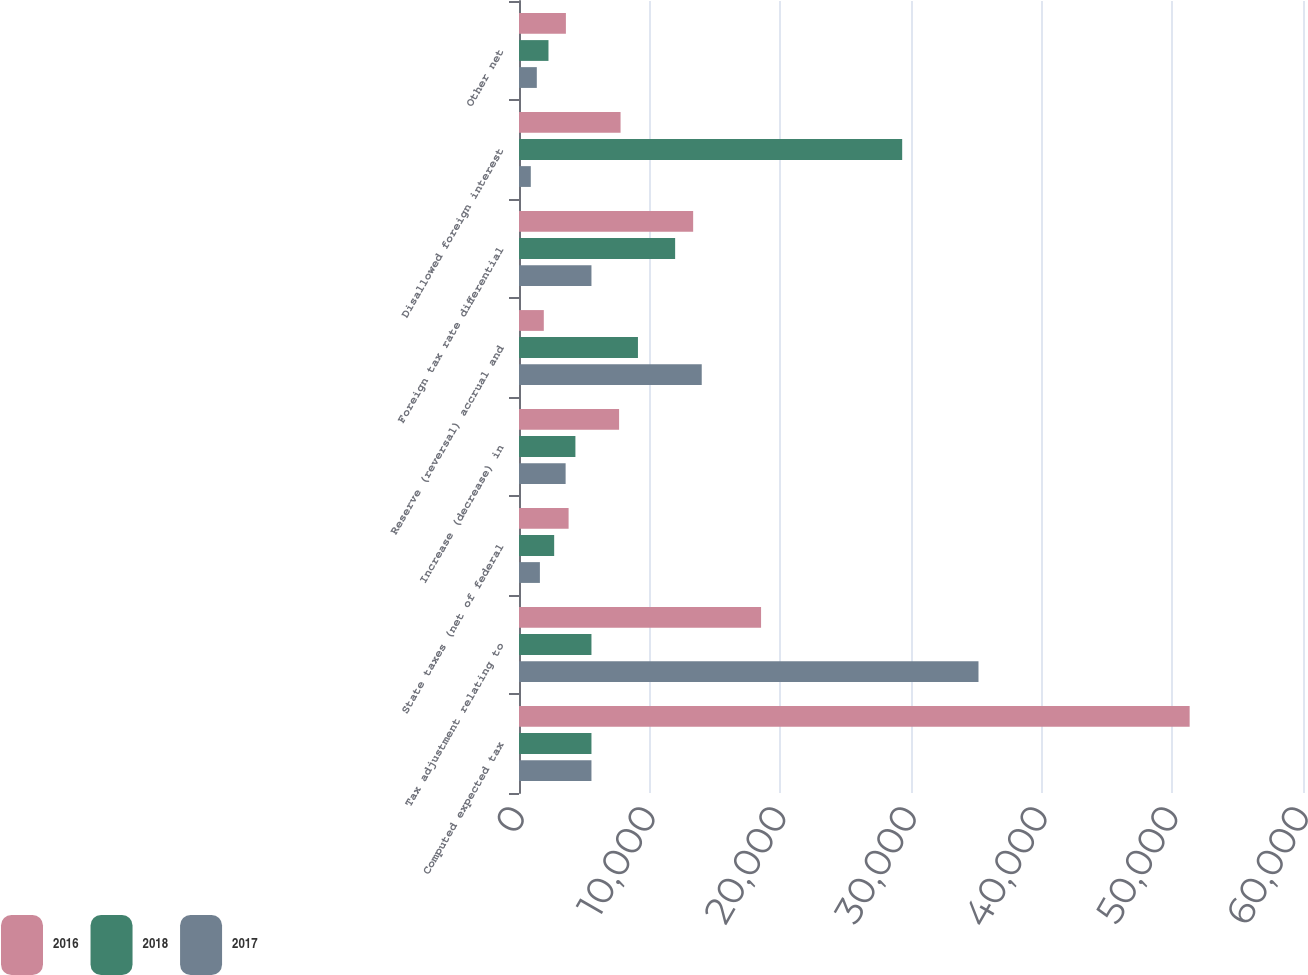<chart> <loc_0><loc_0><loc_500><loc_500><stacked_bar_chart><ecel><fcel>Computed expected tax<fcel>Tax adjustment relating to<fcel>State taxes (net of federal<fcel>Increase (decrease) in<fcel>Reserve (reversal) accrual and<fcel>Foreign tax rate differential<fcel>Disallowed foreign interest<fcel>Other net<nl><fcel>2016<fcel>51325<fcel>18526<fcel>3796<fcel>7660<fcel>1898<fcel>13328<fcel>7773<fcel>3589<nl><fcel>2018<fcel>5545<fcel>5545<fcel>2692<fcel>4317<fcel>9103<fcel>11949<fcel>29325<fcel>2256<nl><fcel>2017<fcel>5545<fcel>35165<fcel>1599<fcel>3568<fcel>13985<fcel>5545<fcel>903<fcel>1363<nl></chart> 